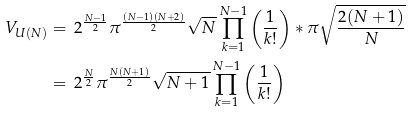Convert formula to latex. <formula><loc_0><loc_0><loc_500><loc_500>V _ { U ( N ) } & = \, 2 ^ { \frac { N - 1 } { 2 } } \pi ^ { \frac { ( N - 1 ) ( N + 2 ) } { 2 } } \sqrt { N } \prod ^ { N - 1 } _ { k = 1 } \left ( \frac { 1 } { k ! } \right ) * \pi \sqrt { \frac { 2 ( N + 1 ) } { N } } \\ & = \, 2 ^ { \frac { N } { 2 } } \pi ^ { \frac { N ( N + 1 ) } { 2 } } \sqrt { N + 1 } \prod ^ { N - 1 } _ { k = 1 } \left ( \frac { 1 } { k ! } \right )</formula> 